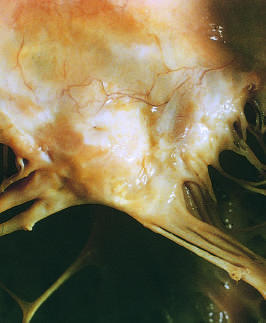s high-power view of another region marked left atrial dilation as seen from above the valve?
Answer the question using a single word or phrase. No 